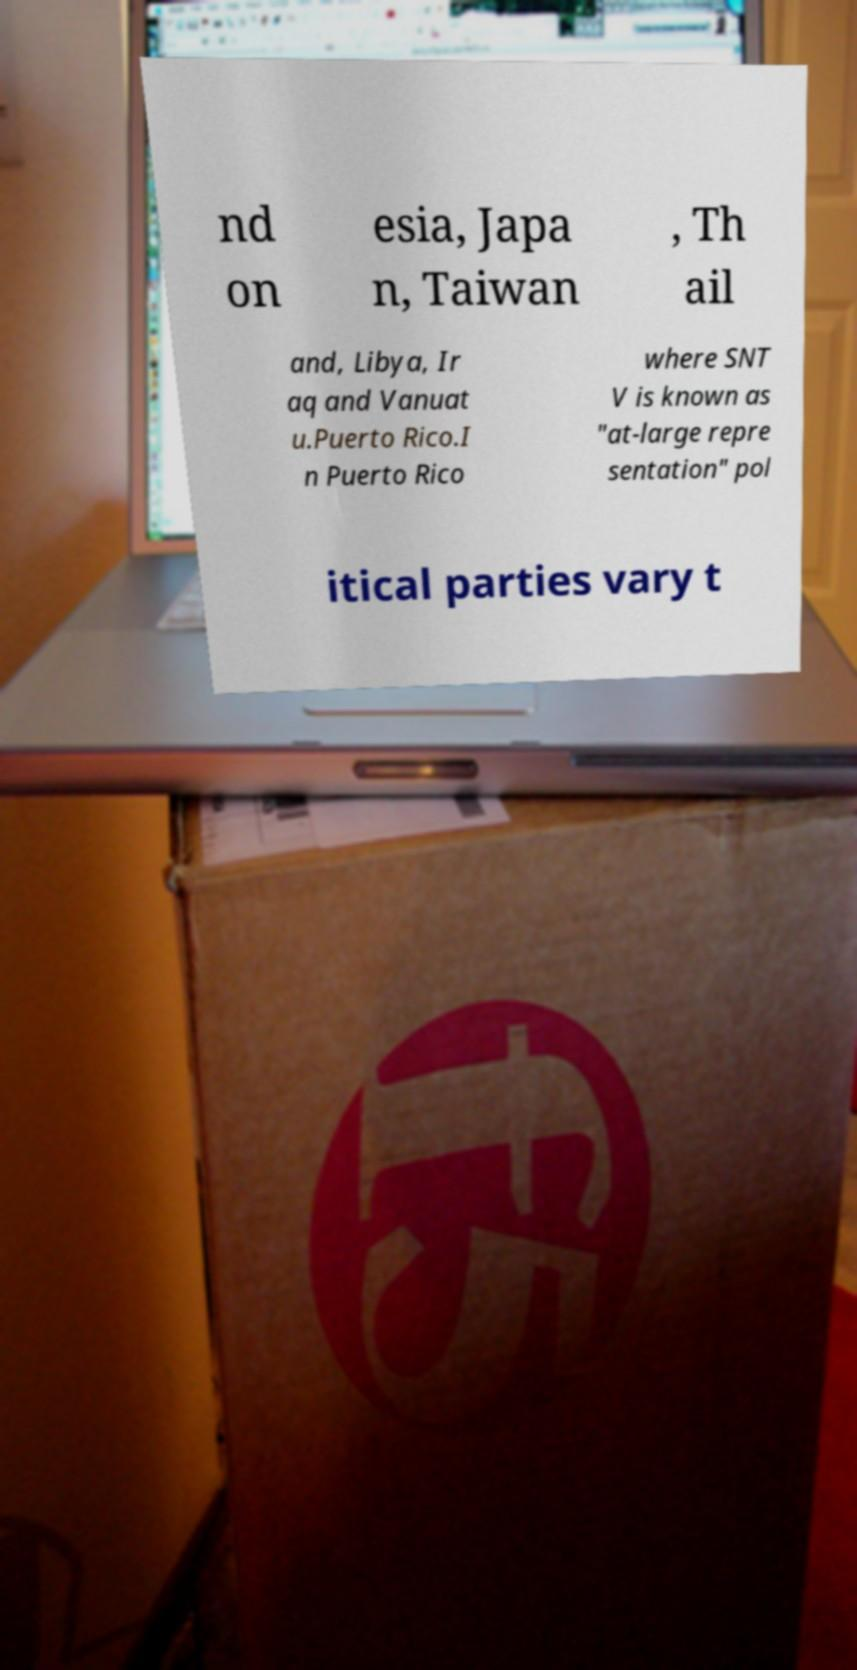Can you read and provide the text displayed in the image?This photo seems to have some interesting text. Can you extract and type it out for me? nd on esia, Japa n, Taiwan , Th ail and, Libya, Ir aq and Vanuat u.Puerto Rico.I n Puerto Rico where SNT V is known as "at-large repre sentation" pol itical parties vary t 